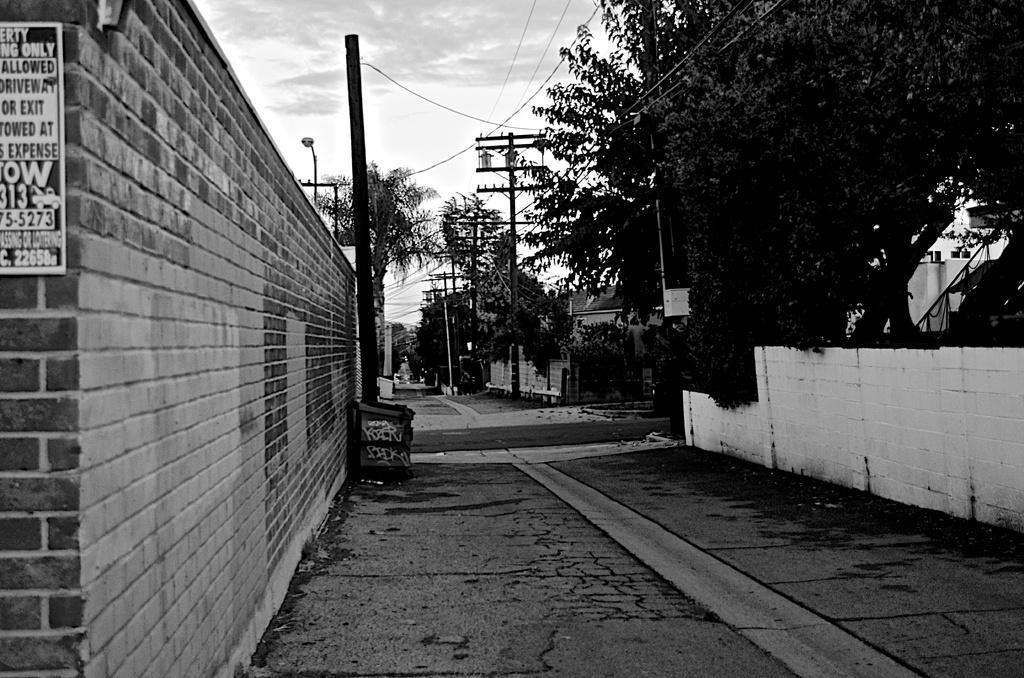Describe this image in one or two sentences. In this picture we can see few buildings, poles, cables and trees, on the left side of the image we can see a poster on the wall, we can see clouds and it is a black and white photography. 